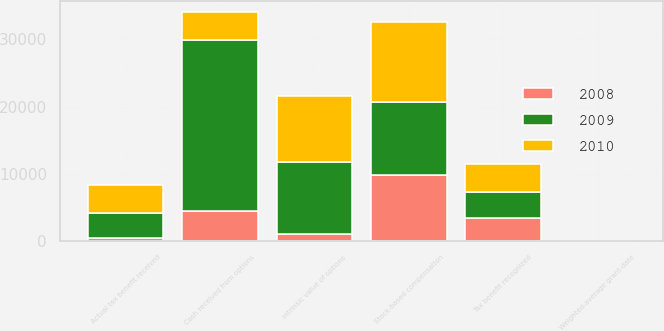Convert chart. <chart><loc_0><loc_0><loc_500><loc_500><stacked_bar_chart><ecel><fcel>Stock-based compensation<fcel>Tax benefit recognized<fcel>Weighted-average grant-date<fcel>Intrinsic value of options<fcel>Cash received from options<fcel>Actual tax benefit received<nl><fcel>2010<fcel>11848<fcel>4147<fcel>15.53<fcel>9731<fcel>4147<fcel>4236<nl><fcel>2008<fcel>9860<fcel>3451<fcel>5.5<fcel>1088<fcel>4430<fcel>381<nl><fcel>2009<fcel>10823<fcel>3788<fcel>8.87<fcel>10700<fcel>25473<fcel>3745<nl></chart> 